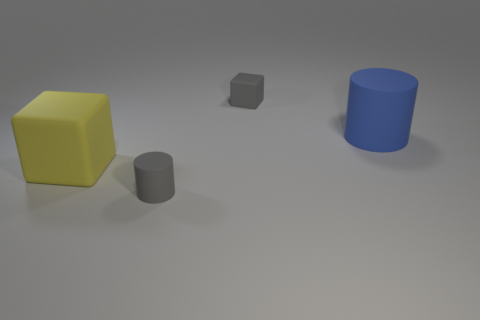Add 3 big red cylinders. How many objects exist? 7 Add 3 small rubber cubes. How many small rubber cubes are left? 4 Add 3 cubes. How many cubes exist? 5 Subtract 0 purple cubes. How many objects are left? 4 Subtract all large metal objects. Subtract all yellow blocks. How many objects are left? 3 